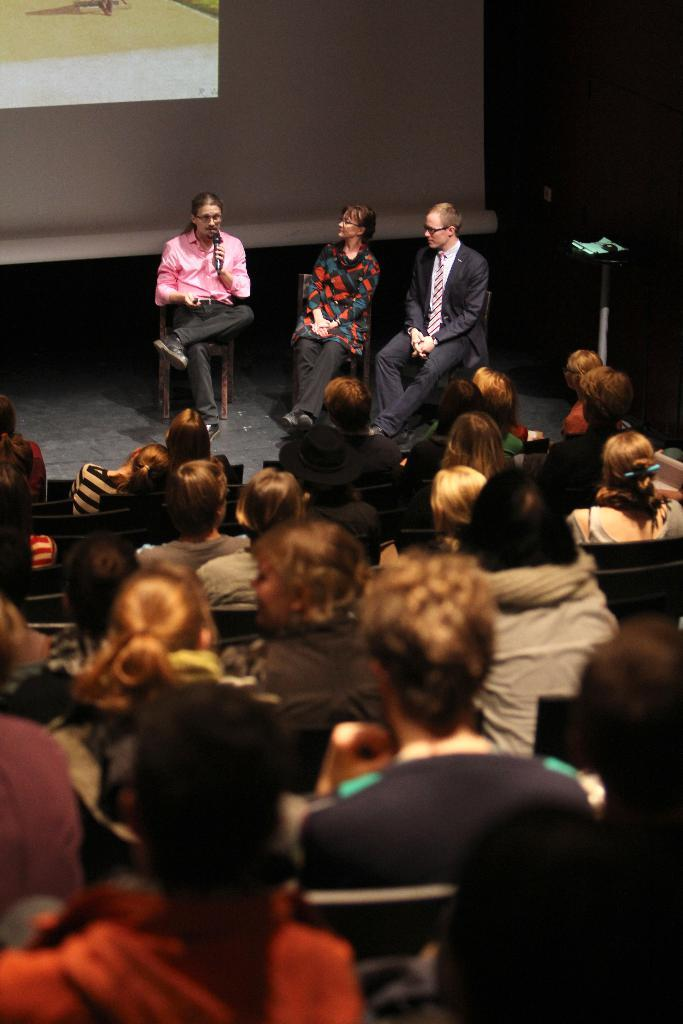How many people are in the image? There are three persons in the image. What are the persons wearing? The persons are wearing clothes. What are the persons doing in the image? The persons are sitting on chairs. Where are the persons located in relation to the crowd? The persons are in front of a crowd. What is present in the top left of the image? There is a screen in the top left of the image. What type of button can be seen on the throne in the image? There is no throne or button present in the image. 